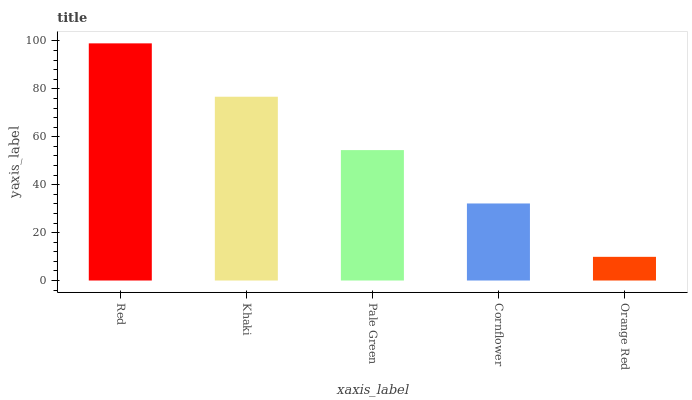Is Orange Red the minimum?
Answer yes or no. Yes. Is Red the maximum?
Answer yes or no. Yes. Is Khaki the minimum?
Answer yes or no. No. Is Khaki the maximum?
Answer yes or no. No. Is Red greater than Khaki?
Answer yes or no. Yes. Is Khaki less than Red?
Answer yes or no. Yes. Is Khaki greater than Red?
Answer yes or no. No. Is Red less than Khaki?
Answer yes or no. No. Is Pale Green the high median?
Answer yes or no. Yes. Is Pale Green the low median?
Answer yes or no. Yes. Is Cornflower the high median?
Answer yes or no. No. Is Red the low median?
Answer yes or no. No. 